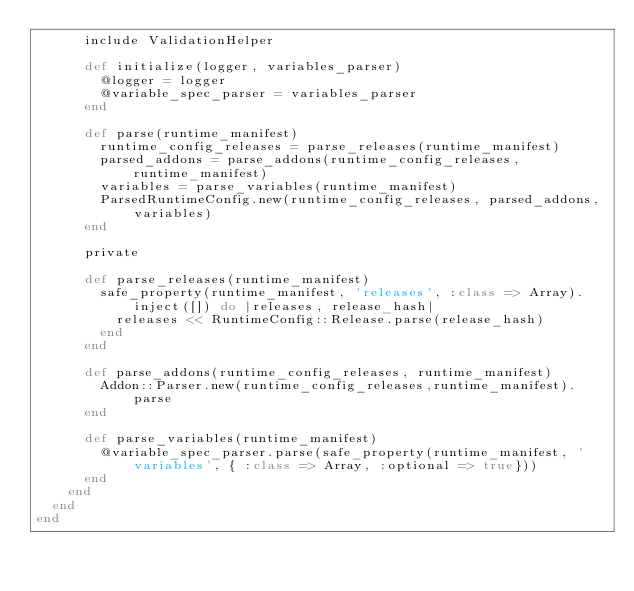Convert code to text. <code><loc_0><loc_0><loc_500><loc_500><_Ruby_>      include ValidationHelper

      def initialize(logger, variables_parser)
        @logger = logger
        @variable_spec_parser = variables_parser
      end

      def parse(runtime_manifest)
        runtime_config_releases = parse_releases(runtime_manifest)
        parsed_addons = parse_addons(runtime_config_releases, runtime_manifest)
        variables = parse_variables(runtime_manifest)
        ParsedRuntimeConfig.new(runtime_config_releases, parsed_addons, variables)
      end

      private

      def parse_releases(runtime_manifest)
        safe_property(runtime_manifest, 'releases', :class => Array).inject([]) do |releases, release_hash|
          releases << RuntimeConfig::Release.parse(release_hash)
        end
      end

      def parse_addons(runtime_config_releases, runtime_manifest)
        Addon::Parser.new(runtime_config_releases,runtime_manifest).parse
      end

      def parse_variables(runtime_manifest)
        @variable_spec_parser.parse(safe_property(runtime_manifest, 'variables', { :class => Array, :optional => true}))
      end
    end
  end
end
</code> 